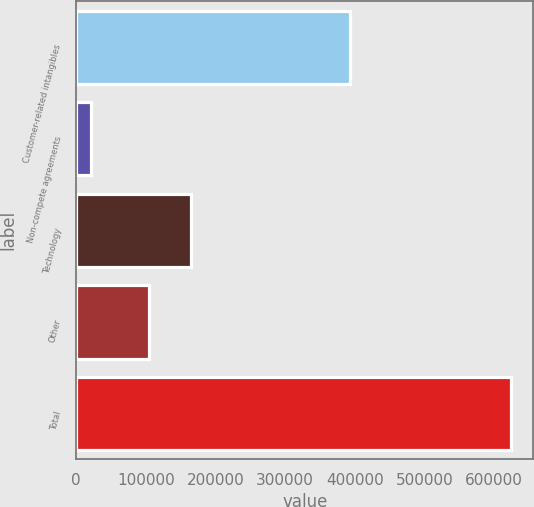Convert chart to OTSL. <chart><loc_0><loc_0><loc_500><loc_500><bar_chart><fcel>Customer-related intangibles<fcel>Non-compete agreements<fcel>Technology<fcel>Other<fcel>Total<nl><fcel>393185<fcel>21428<fcel>164510<fcel>104184<fcel>624693<nl></chart> 